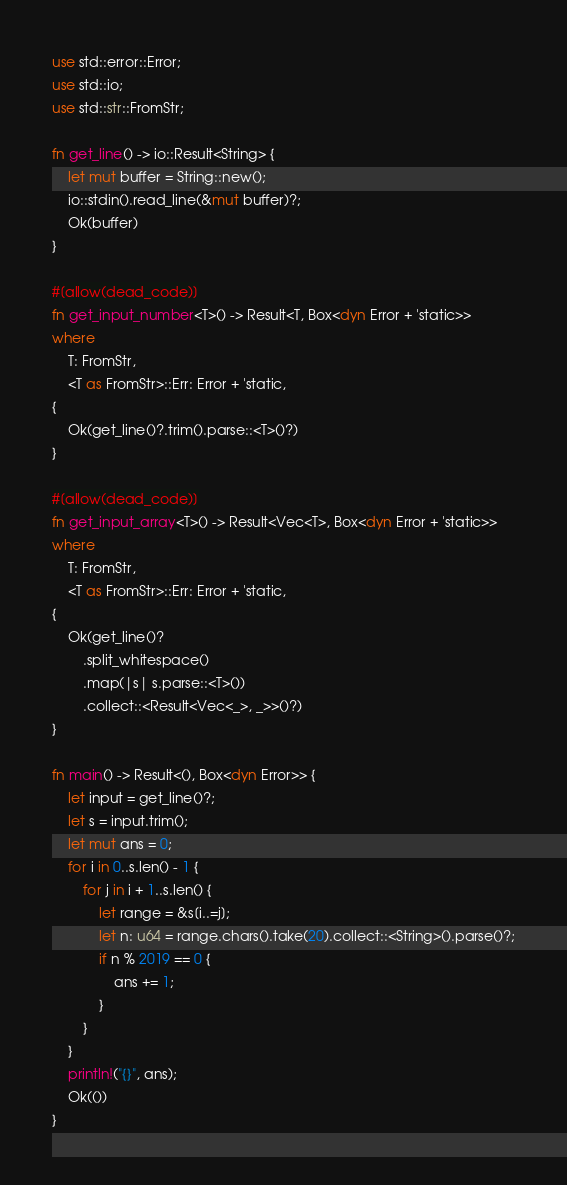<code> <loc_0><loc_0><loc_500><loc_500><_Rust_>use std::error::Error;
use std::io;
use std::str::FromStr;

fn get_line() -> io::Result<String> {
	let mut buffer = String::new();
	io::stdin().read_line(&mut buffer)?;
	Ok(buffer)
}

#[allow(dead_code)]
fn get_input_number<T>() -> Result<T, Box<dyn Error + 'static>>
where
	T: FromStr,
	<T as FromStr>::Err: Error + 'static,
{
	Ok(get_line()?.trim().parse::<T>()?)
}

#[allow(dead_code)]
fn get_input_array<T>() -> Result<Vec<T>, Box<dyn Error + 'static>>
where
	T: FromStr,
	<T as FromStr>::Err: Error + 'static,
{
	Ok(get_line()?
		.split_whitespace()
		.map(|s| s.parse::<T>())
		.collect::<Result<Vec<_>, _>>()?)
}

fn main() -> Result<(), Box<dyn Error>> {
	let input = get_line()?;
	let s = input.trim();
	let mut ans = 0;
	for i in 0..s.len() - 1 {
		for j in i + 1..s.len() {
			let range = &s[i..=j];
			let n: u64 = range.chars().take(20).collect::<String>().parse()?;
			if n % 2019 == 0 {
				ans += 1;
			}
		}
	}
	println!("{}", ans);
	Ok(())
}
</code> 